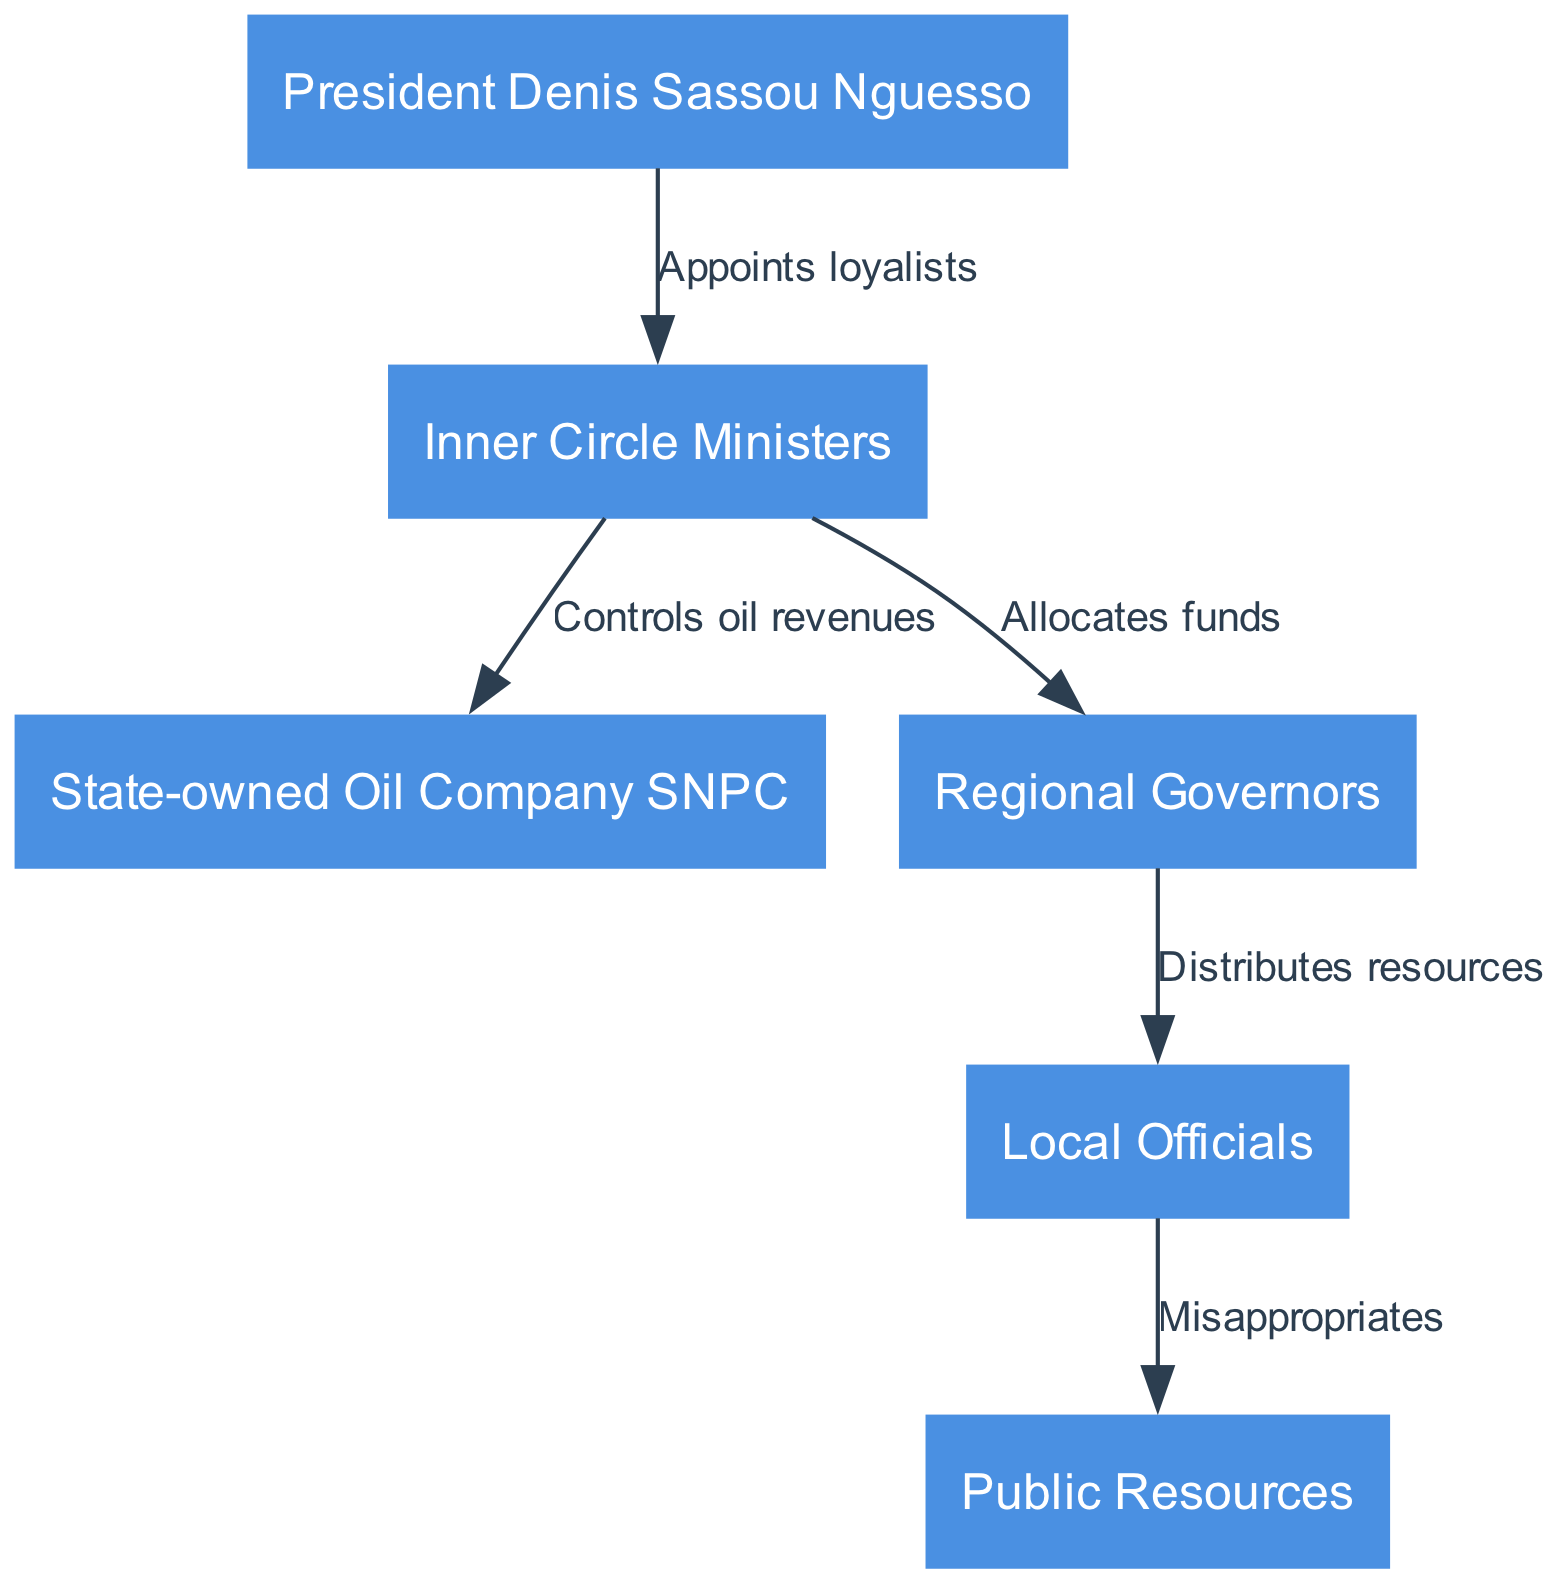What is the highest node in the food chain? The food chain begins with President Denis Sassou Nguesso, who is at the top of the hierarchy. This is seen as he has edges pointing to Inner Circle Ministers.
Answer: President Denis Sassou Nguesso How many nodes are in the diagram? The diagram contains six nodes: President Denis Sassou Nguesso, Inner Circle Ministers, State-owned Oil Company SNPC, Regional Governors, Local Officials, and Public Resources.
Answer: 6 Which node manages oil revenues? The Inner Circle Ministers control the oil revenues, as indicated by the directed edge to the State-owned Oil Company SNPC labeled "Controls oil revenues."
Answer: Inner Circle Ministers What action do Local Officials take concerning public resources? Local Officials misappropriate public resources, which is illustrated by the edge leading from Local Officials to Public Resources labeled "Misappropriates."
Answer: Misappropriates Who allocates funds to Regional Governors? The Inner Circle Ministers are responsible for allocating funds to Regional Governors, as depicted by the edge labeled "Allocates funds."
Answer: Inner Circle Ministers How many edges connect the nodes? There are five edges in the diagram, which represent the relationships between the nodes. Each edge illustrates an action or control from one node to another.
Answer: 5 What is the relationship between Inner Circle Ministers and Regional Governors? The Inner Circle Ministers allocate funds to Regional Governors, which is shown by the directed edge from Inner Circle Ministers to Regional Governors.
Answer: Allocates funds Which node distributes resources? The Regional Governors are responsible for distributing resources, as demonstrated by the edge leading to Local Officials labeled "Distributes resources."
Answer: Regional Governors What does the arrow from Local Officials to Public Resources signify? The edge from Local Officials to Public Resources signifies that Local Officials misappropriate these resources, which implies a misuse of authority or funds.
Answer: Misappropriates 